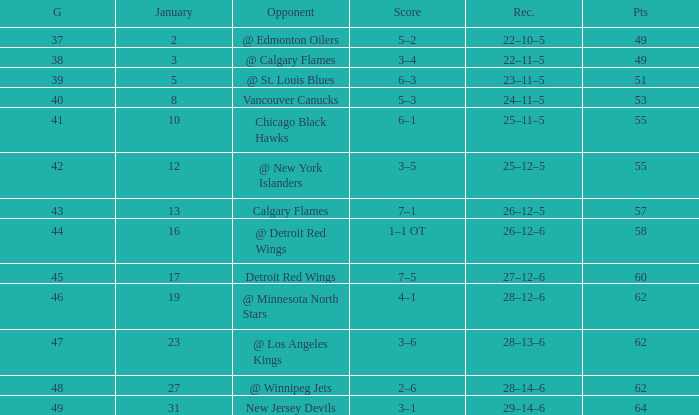How many Games have a Score of 2–6, and Points larger than 62? 0.0. 